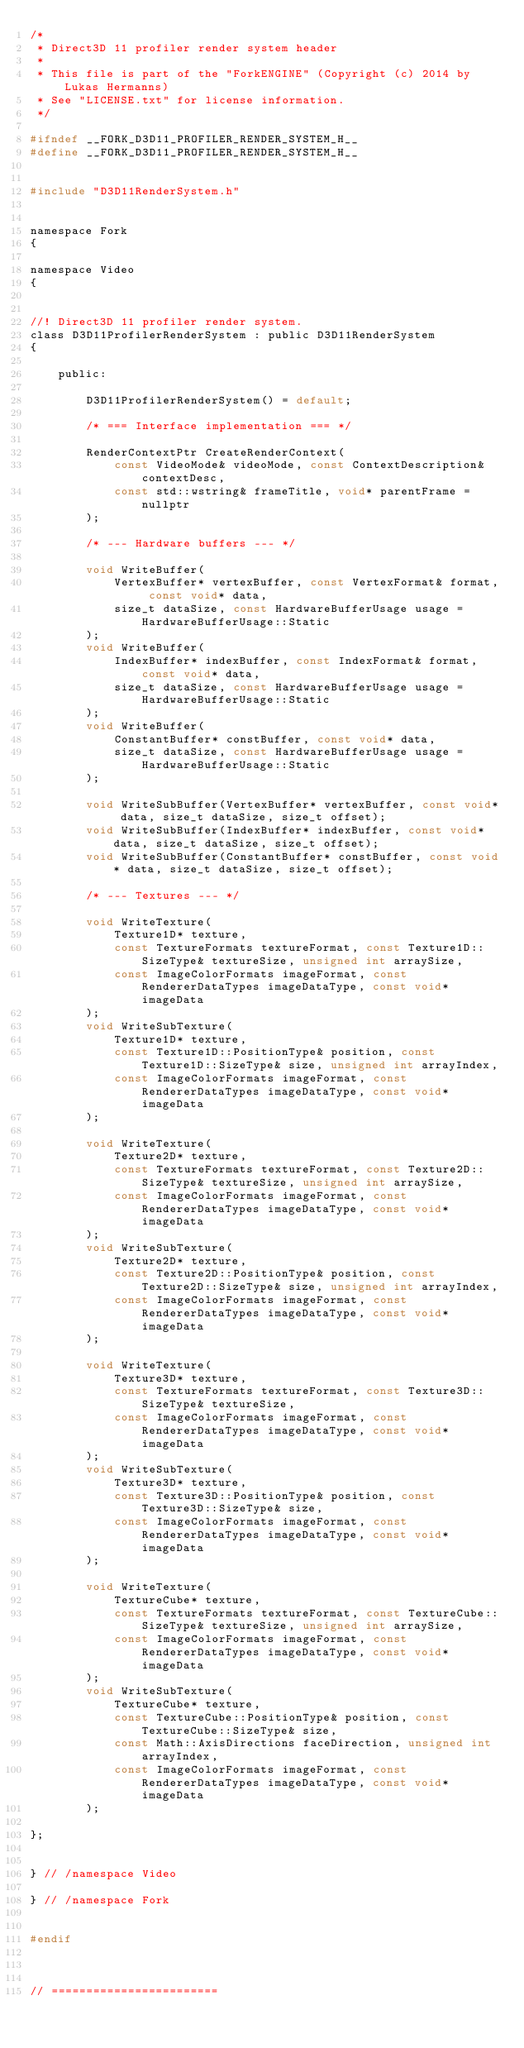<code> <loc_0><loc_0><loc_500><loc_500><_C_>/*
 * Direct3D 11 profiler render system header
 * 
 * This file is part of the "ForkENGINE" (Copyright (c) 2014 by Lukas Hermanns)
 * See "LICENSE.txt" for license information.
 */

#ifndef __FORK_D3D11_PROFILER_RENDER_SYSTEM_H__
#define __FORK_D3D11_PROFILER_RENDER_SYSTEM_H__


#include "D3D11RenderSystem.h"


namespace Fork
{

namespace Video
{


//! Direct3D 11 profiler render system.
class D3D11ProfilerRenderSystem : public D3D11RenderSystem
{
    
    public:
        
        D3D11ProfilerRenderSystem() = default;
        
        /* === Interface implementation === */

        RenderContextPtr CreateRenderContext(
            const VideoMode& videoMode, const ContextDescription& contextDesc,
            const std::wstring& frameTitle, void* parentFrame = nullptr
        );

        /* --- Hardware buffers --- */

        void WriteBuffer(
            VertexBuffer* vertexBuffer, const VertexFormat& format, const void* data,
            size_t dataSize, const HardwareBufferUsage usage = HardwareBufferUsage::Static
        );
        void WriteBuffer(
            IndexBuffer* indexBuffer, const IndexFormat& format, const void* data,
            size_t dataSize, const HardwareBufferUsage usage = HardwareBufferUsage::Static
        );
        void WriteBuffer(
            ConstantBuffer* constBuffer, const void* data,
            size_t dataSize, const HardwareBufferUsage usage = HardwareBufferUsage::Static
        );

        void WriteSubBuffer(VertexBuffer* vertexBuffer, const void* data, size_t dataSize, size_t offset);
        void WriteSubBuffer(IndexBuffer* indexBuffer, const void* data, size_t dataSize, size_t offset);
        void WriteSubBuffer(ConstantBuffer* constBuffer, const void* data, size_t dataSize, size_t offset);

        /* --- Textures --- */

        void WriteTexture(
            Texture1D* texture,
            const TextureFormats textureFormat, const Texture1D::SizeType& textureSize, unsigned int arraySize,
            const ImageColorFormats imageFormat, const RendererDataTypes imageDataType, const void* imageData
        );
        void WriteSubTexture(
            Texture1D* texture,
            const Texture1D::PositionType& position, const Texture1D::SizeType& size, unsigned int arrayIndex,
            const ImageColorFormats imageFormat, const RendererDataTypes imageDataType, const void* imageData
        );

        void WriteTexture(
            Texture2D* texture,
            const TextureFormats textureFormat, const Texture2D::SizeType& textureSize, unsigned int arraySize,
            const ImageColorFormats imageFormat, const RendererDataTypes imageDataType, const void* imageData
        );
        void WriteSubTexture(
            Texture2D* texture,
            const Texture2D::PositionType& position, const Texture2D::SizeType& size, unsigned int arrayIndex,
            const ImageColorFormats imageFormat, const RendererDataTypes imageDataType, const void* imageData
        );

        void WriteTexture(
            Texture3D* texture,
            const TextureFormats textureFormat, const Texture3D::SizeType& textureSize,
            const ImageColorFormats imageFormat, const RendererDataTypes imageDataType, const void* imageData
        );
        void WriteSubTexture(
            Texture3D* texture,
            const Texture3D::PositionType& position, const Texture3D::SizeType& size,
            const ImageColorFormats imageFormat, const RendererDataTypes imageDataType, const void* imageData
        );

        void WriteTexture(
            TextureCube* texture,
            const TextureFormats textureFormat, const TextureCube::SizeType& textureSize, unsigned int arraySize,
            const ImageColorFormats imageFormat, const RendererDataTypes imageDataType, const void* imageData
        );
        void WriteSubTexture(
            TextureCube* texture,
            const TextureCube::PositionType& position, const TextureCube::SizeType& size,
            const Math::AxisDirections faceDirection, unsigned int arrayIndex,
            const ImageColorFormats imageFormat, const RendererDataTypes imageDataType, const void* imageData
        );

};


} // /namespace Video

} // /namespace Fork


#endif



// ========================</code> 